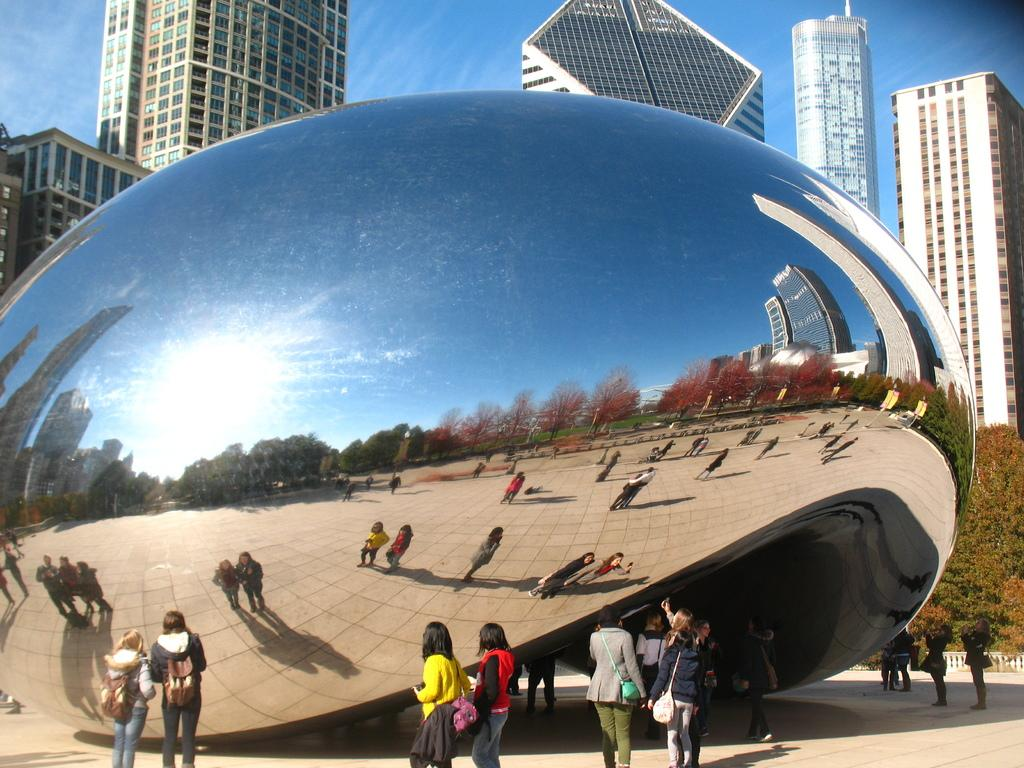What type of structures can be seen in the image? There are buildings in the image. What other elements are present in the image besides buildings? There are trees, people, and a mirror in the image. What is visible in the sky in the image? The sky is visible in the image. What can be seen in the mirror in the image? The reflection of buildings, trees, sky, and people can be seen in the mirror. Where is the baseball game being played in the image? There is no baseball game present in the image. What type of cushion is being used by the people in the image? There is no cushion visible in the image. 